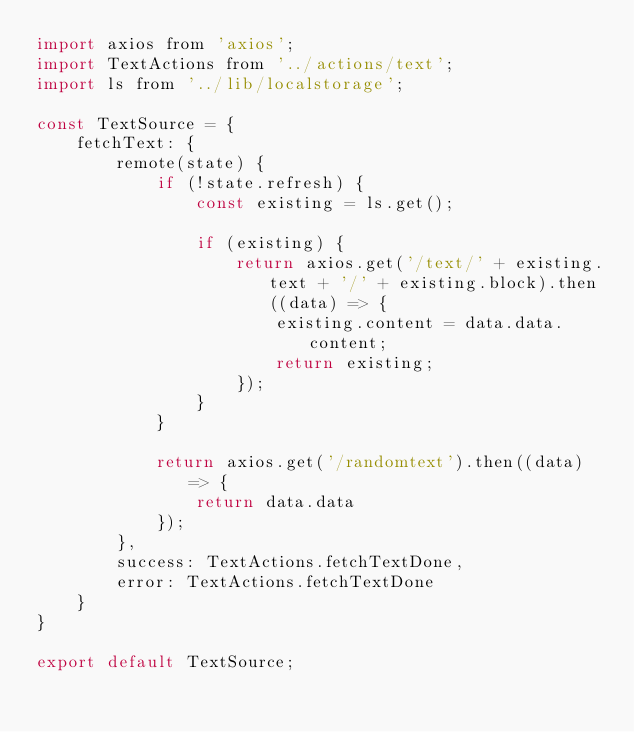<code> <loc_0><loc_0><loc_500><loc_500><_JavaScript_>import axios from 'axios';
import TextActions from '../actions/text';
import ls from '../lib/localstorage';

const TextSource = {
    fetchText: {
        remote(state) {
            if (!state.refresh) {
                const existing = ls.get();

                if (existing) {
                    return axios.get('/text/' + existing.text + '/' + existing.block).then((data) => {
                        existing.content = data.data.content;
                        return existing;
                    });
                }
            }

            return axios.get('/randomtext').then((data) => {
                return data.data
            });
        },
        success: TextActions.fetchTextDone,
        error: TextActions.fetchTextDone
    }
}

export default TextSource;</code> 